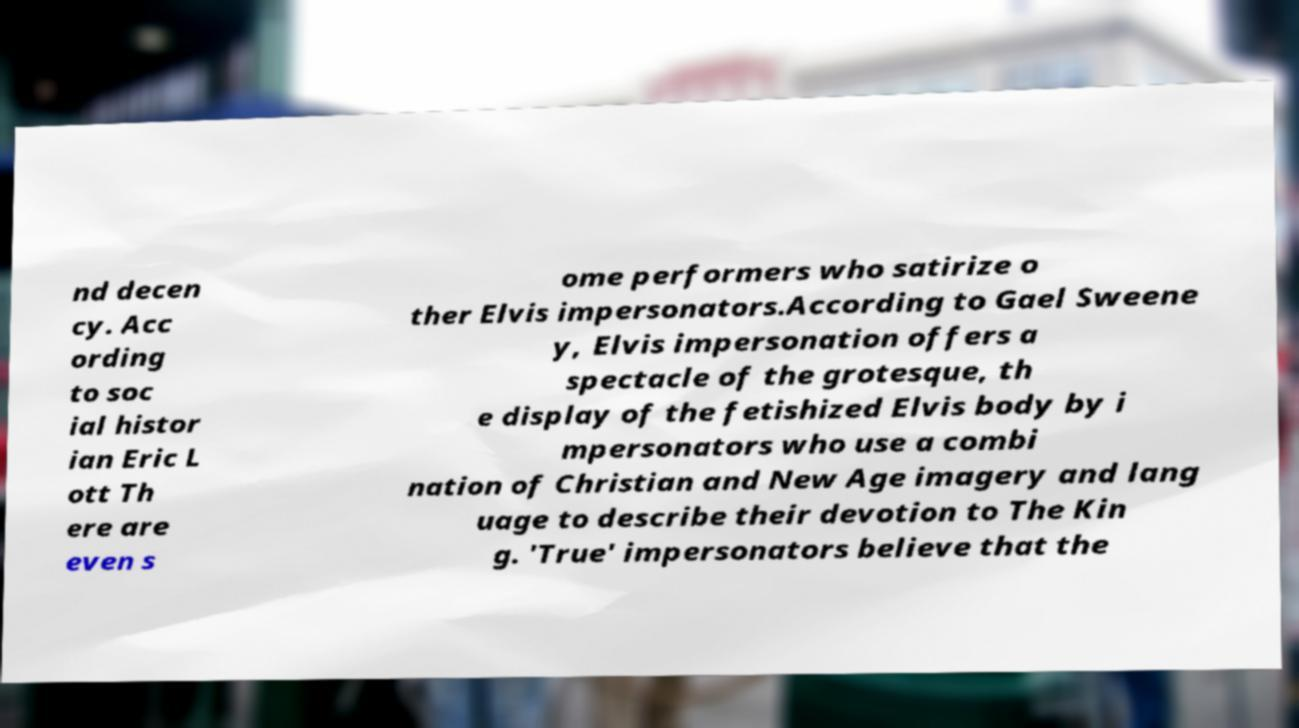Please identify and transcribe the text found in this image. nd decen cy. Acc ording to soc ial histor ian Eric L ott Th ere are even s ome performers who satirize o ther Elvis impersonators.According to Gael Sweene y, Elvis impersonation offers a spectacle of the grotesque, th e display of the fetishized Elvis body by i mpersonators who use a combi nation of Christian and New Age imagery and lang uage to describe their devotion to The Kin g. 'True' impersonators believe that the 